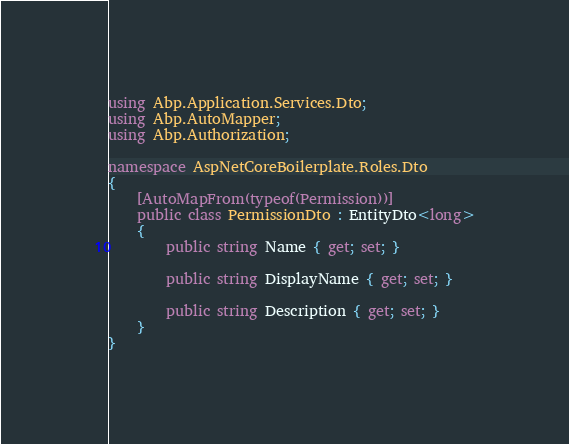Convert code to text. <code><loc_0><loc_0><loc_500><loc_500><_C#_>using Abp.Application.Services.Dto;
using Abp.AutoMapper;
using Abp.Authorization;

namespace AspNetCoreBoilerplate.Roles.Dto
{
    [AutoMapFrom(typeof(Permission))]
    public class PermissionDto : EntityDto<long>
    {
        public string Name { get; set; }

        public string DisplayName { get; set; }

        public string Description { get; set; }
    }
}
</code> 